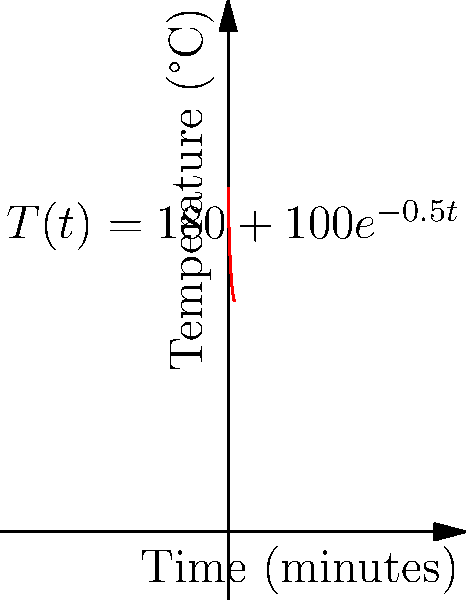During an Ethiopian coffee ceremony, the temperature of roasting coffee beans follows the curve $T(t) = 180 + 100e^{-0.5t}$, where $T$ is the temperature in °C and $t$ is the time in minutes. At what rate is the temperature changing after 2 minutes of roasting? To find the rate of change of temperature with respect to time at $t = 2$ minutes, we need to calculate the derivative of $T(t)$ and evaluate it at $t = 2$.

Step 1: Find the derivative of $T(t)$.
$T(t) = 180 + 100e^{-0.5t}$
$\frac{dT}{dt} = 0 + 100 \cdot (-0.5)e^{-0.5t}$ (using the chain rule)
$\frac{dT}{dt} = -50e^{-0.5t}$

Step 2: Evaluate the derivative at $t = 2$.
$\frac{dT}{dt}|_{t=2} = -50e^{-0.5(2)}$
$= -50e^{-1}$
$= -50 \cdot \frac{1}{e}$
$\approx -18.39$ °C/min

Therefore, after 2 minutes of roasting, the temperature is decreasing at a rate of approximately 18.39 °C per minute.
Answer: $-18.39$ °C/min 